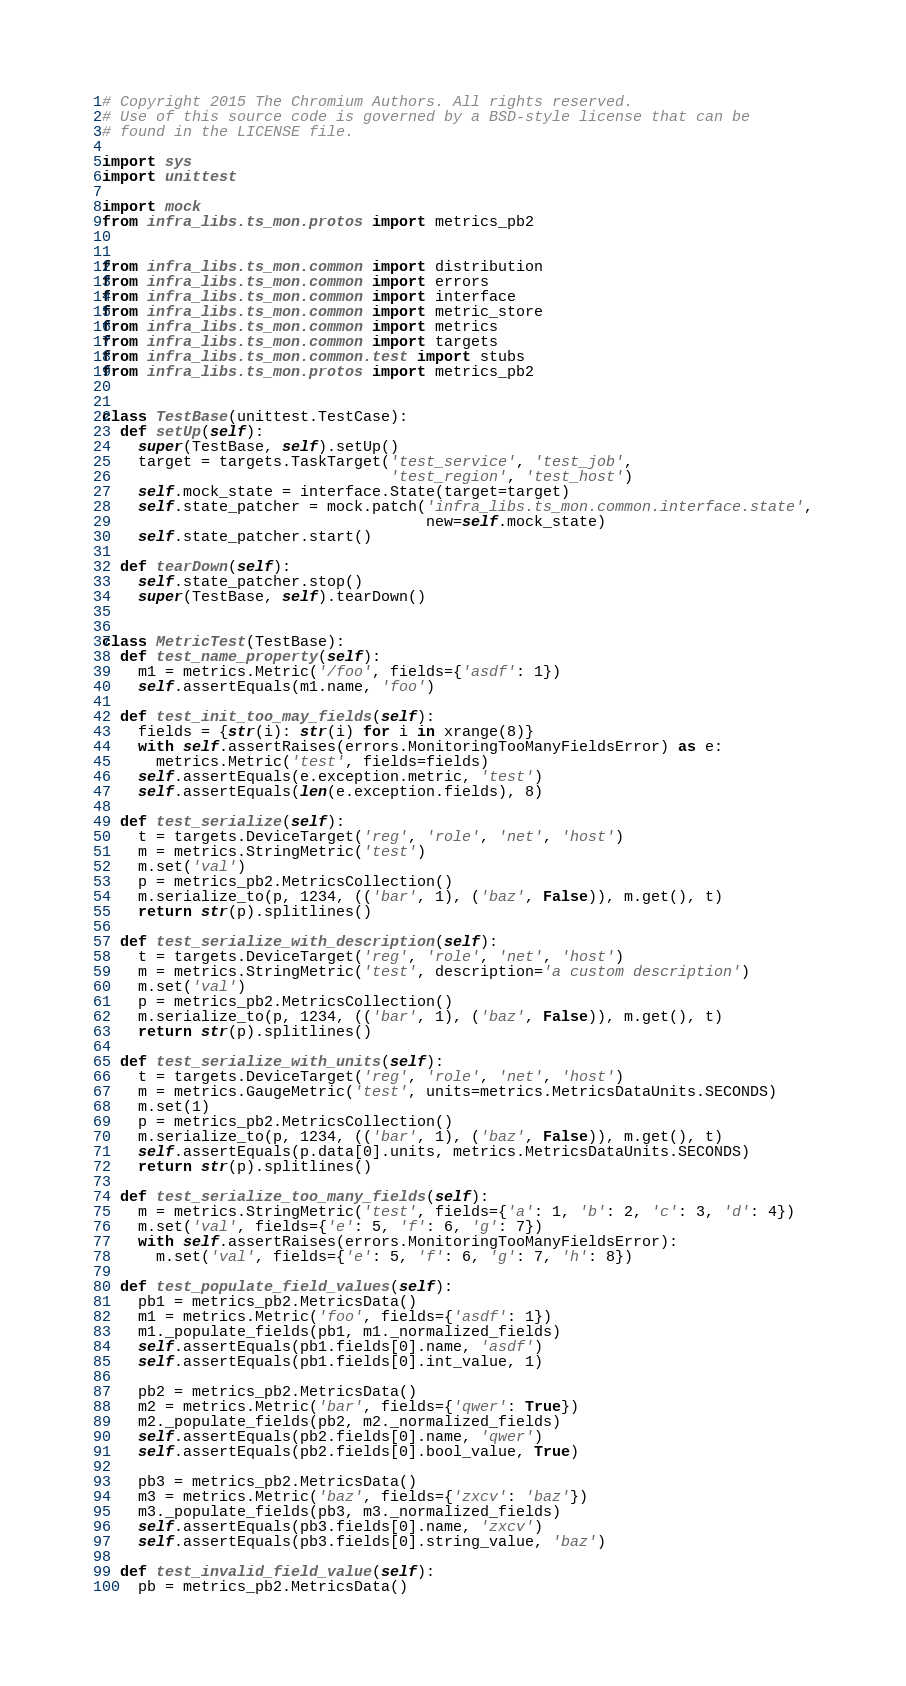Convert code to text. <code><loc_0><loc_0><loc_500><loc_500><_Python_># Copyright 2015 The Chromium Authors. All rights reserved.
# Use of this source code is governed by a BSD-style license that can be
# found in the LICENSE file.

import sys
import unittest

import mock
from infra_libs.ts_mon.protos import metrics_pb2


from infra_libs.ts_mon.common import distribution
from infra_libs.ts_mon.common import errors
from infra_libs.ts_mon.common import interface
from infra_libs.ts_mon.common import metric_store
from infra_libs.ts_mon.common import metrics
from infra_libs.ts_mon.common import targets
from infra_libs.ts_mon.common.test import stubs
from infra_libs.ts_mon.protos import metrics_pb2


class TestBase(unittest.TestCase):
  def setUp(self):
    super(TestBase, self).setUp()
    target = targets.TaskTarget('test_service', 'test_job',
                                'test_region', 'test_host')
    self.mock_state = interface.State(target=target)
    self.state_patcher = mock.patch('infra_libs.ts_mon.common.interface.state',
                                    new=self.mock_state)
    self.state_patcher.start()

  def tearDown(self):
    self.state_patcher.stop()
    super(TestBase, self).tearDown()


class MetricTest(TestBase):
  def test_name_property(self):
    m1 = metrics.Metric('/foo', fields={'asdf': 1})
    self.assertEquals(m1.name, 'foo')

  def test_init_too_may_fields(self):
    fields = {str(i): str(i) for i in xrange(8)}
    with self.assertRaises(errors.MonitoringTooManyFieldsError) as e:
      metrics.Metric('test', fields=fields)
    self.assertEquals(e.exception.metric, 'test')
    self.assertEquals(len(e.exception.fields), 8)

  def test_serialize(self):
    t = targets.DeviceTarget('reg', 'role', 'net', 'host')
    m = metrics.StringMetric('test')
    m.set('val')
    p = metrics_pb2.MetricsCollection()
    m.serialize_to(p, 1234, (('bar', 1), ('baz', False)), m.get(), t)
    return str(p).splitlines()

  def test_serialize_with_description(self):
    t = targets.DeviceTarget('reg', 'role', 'net', 'host')
    m = metrics.StringMetric('test', description='a custom description')
    m.set('val')
    p = metrics_pb2.MetricsCollection()
    m.serialize_to(p, 1234, (('bar', 1), ('baz', False)), m.get(), t)
    return str(p).splitlines()

  def test_serialize_with_units(self):
    t = targets.DeviceTarget('reg', 'role', 'net', 'host')
    m = metrics.GaugeMetric('test', units=metrics.MetricsDataUnits.SECONDS)
    m.set(1)
    p = metrics_pb2.MetricsCollection()
    m.serialize_to(p, 1234, (('bar', 1), ('baz', False)), m.get(), t)
    self.assertEquals(p.data[0].units, metrics.MetricsDataUnits.SECONDS)
    return str(p).splitlines()

  def test_serialize_too_many_fields(self):
    m = metrics.StringMetric('test', fields={'a': 1, 'b': 2, 'c': 3, 'd': 4})
    m.set('val', fields={'e': 5, 'f': 6, 'g': 7})
    with self.assertRaises(errors.MonitoringTooManyFieldsError):
      m.set('val', fields={'e': 5, 'f': 6, 'g': 7, 'h': 8})

  def test_populate_field_values(self):
    pb1 = metrics_pb2.MetricsData()
    m1 = metrics.Metric('foo', fields={'asdf': 1})
    m1._populate_fields(pb1, m1._normalized_fields)
    self.assertEquals(pb1.fields[0].name, 'asdf')
    self.assertEquals(pb1.fields[0].int_value, 1)

    pb2 = metrics_pb2.MetricsData()
    m2 = metrics.Metric('bar', fields={'qwer': True})
    m2._populate_fields(pb2, m2._normalized_fields)
    self.assertEquals(pb2.fields[0].name, 'qwer')
    self.assertEquals(pb2.fields[0].bool_value, True)

    pb3 = metrics_pb2.MetricsData()
    m3 = metrics.Metric('baz', fields={'zxcv': 'baz'})
    m3._populate_fields(pb3, m3._normalized_fields)
    self.assertEquals(pb3.fields[0].name, 'zxcv')
    self.assertEquals(pb3.fields[0].string_value, 'baz')

  def test_invalid_field_value(self):
    pb = metrics_pb2.MetricsData()</code> 